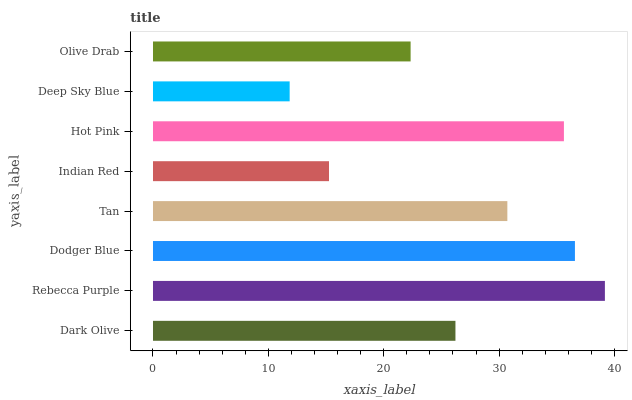Is Deep Sky Blue the minimum?
Answer yes or no. Yes. Is Rebecca Purple the maximum?
Answer yes or no. Yes. Is Dodger Blue the minimum?
Answer yes or no. No. Is Dodger Blue the maximum?
Answer yes or no. No. Is Rebecca Purple greater than Dodger Blue?
Answer yes or no. Yes. Is Dodger Blue less than Rebecca Purple?
Answer yes or no. Yes. Is Dodger Blue greater than Rebecca Purple?
Answer yes or no. No. Is Rebecca Purple less than Dodger Blue?
Answer yes or no. No. Is Tan the high median?
Answer yes or no. Yes. Is Dark Olive the low median?
Answer yes or no. Yes. Is Hot Pink the high median?
Answer yes or no. No. Is Olive Drab the low median?
Answer yes or no. No. 